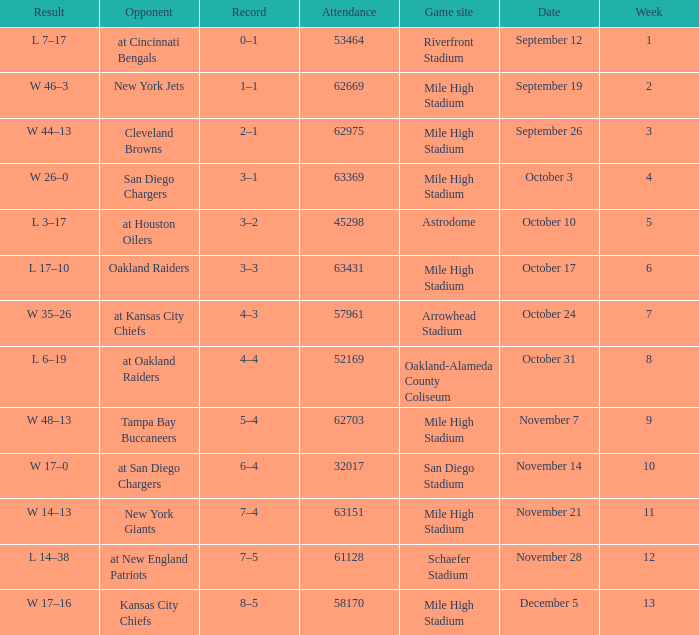What was the week number when the opponent was the New York Jets? 2.0. 